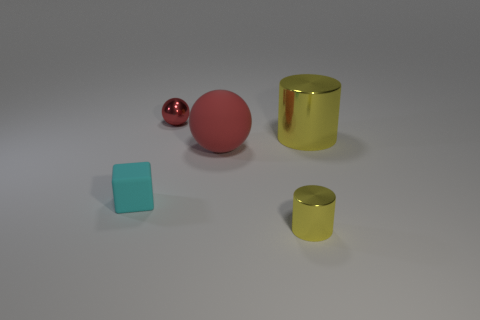What size is the red matte object?
Your answer should be compact. Large. There is a yellow cylinder that is right of the small metallic object to the right of the tiny red ball; what is it made of?
Your response must be concise. Metal. There is a metallic cylinder that is behind the cyan matte block; is its size the same as the small cyan rubber cube?
Your response must be concise. No. Is there a large sphere of the same color as the tiny cube?
Your answer should be very brief. No. How many things are either yellow metal things that are on the left side of the big metallic cylinder or yellow metallic things in front of the large rubber sphere?
Your response must be concise. 1. Is the color of the large rubber object the same as the tiny metallic sphere?
Your answer should be very brief. Yes. There is a sphere that is the same color as the big rubber object; what is it made of?
Offer a terse response. Metal. Are there fewer small things behind the tiny cube than shiny things behind the tiny metal cylinder?
Your response must be concise. Yes. Do the large yellow cylinder and the big red thing have the same material?
Make the answer very short. No. What is the size of the object that is both in front of the big shiny object and to the right of the red rubber sphere?
Ensure brevity in your answer.  Small. 